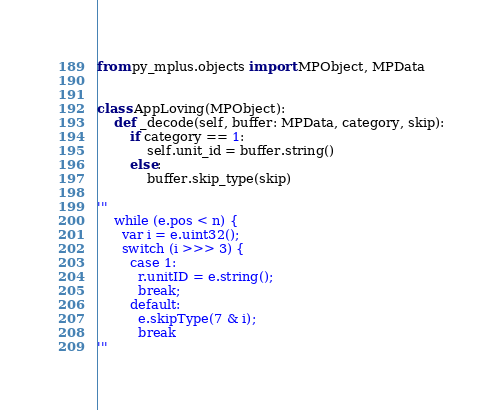Convert code to text. <code><loc_0><loc_0><loc_500><loc_500><_Python_>from py_mplus.objects import MPObject, MPData


class AppLoving(MPObject):
    def _decode(self, buffer: MPData, category, skip):
        if category == 1:
            self.unit_id = buffer.string()
        else:
            buffer.skip_type(skip)

'''
    while (e.pos < n) {
      var i = e.uint32();
      switch (i >>> 3) {
        case 1:
          r.unitID = e.string();
          break;
        default:
          e.skipType(7 & i);
          break
'''</code> 